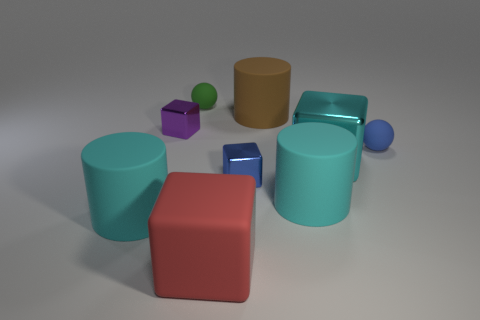There is a big cyan thing that is to the left of the small green thing; is its shape the same as the big red matte object?
Provide a short and direct response. No. What number of other things are the same shape as the small blue matte thing?
Provide a succinct answer. 1. There is a tiny metal thing in front of the small blue matte ball; what is its shape?
Your response must be concise. Cube. Are there any big brown objects made of the same material as the large cyan cube?
Your response must be concise. No. There is a rubber cylinder that is behind the purple block; is its color the same as the large rubber cube?
Provide a succinct answer. No. How big is the purple object?
Offer a very short reply. Small. There is a cyan cylinder on the right side of the large cube to the left of the big brown rubber thing; is there a large block behind it?
Ensure brevity in your answer.  Yes. What number of big cyan cylinders are left of the red thing?
Keep it short and to the point. 1. What number of matte cylinders have the same color as the big metal cube?
Offer a terse response. 2. What number of objects are either cyan matte things to the left of the purple cube or matte cylinders in front of the tiny blue ball?
Offer a terse response. 2. 